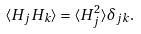<formula> <loc_0><loc_0><loc_500><loc_500>\langle H _ { j } H _ { k } \rangle = \langle H ^ { 2 } _ { j } \rangle \delta _ { j k } .</formula> 